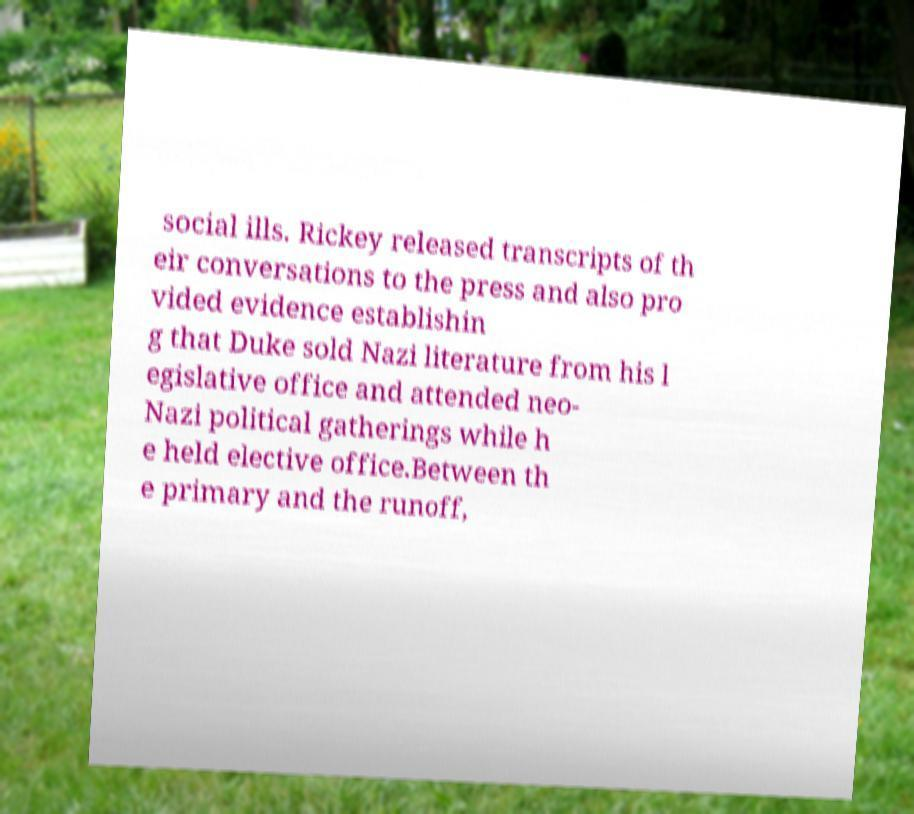I need the written content from this picture converted into text. Can you do that? social ills. Rickey released transcripts of th eir conversations to the press and also pro vided evidence establishin g that Duke sold Nazi literature from his l egislative office and attended neo- Nazi political gatherings while h e held elective office.Between th e primary and the runoff, 